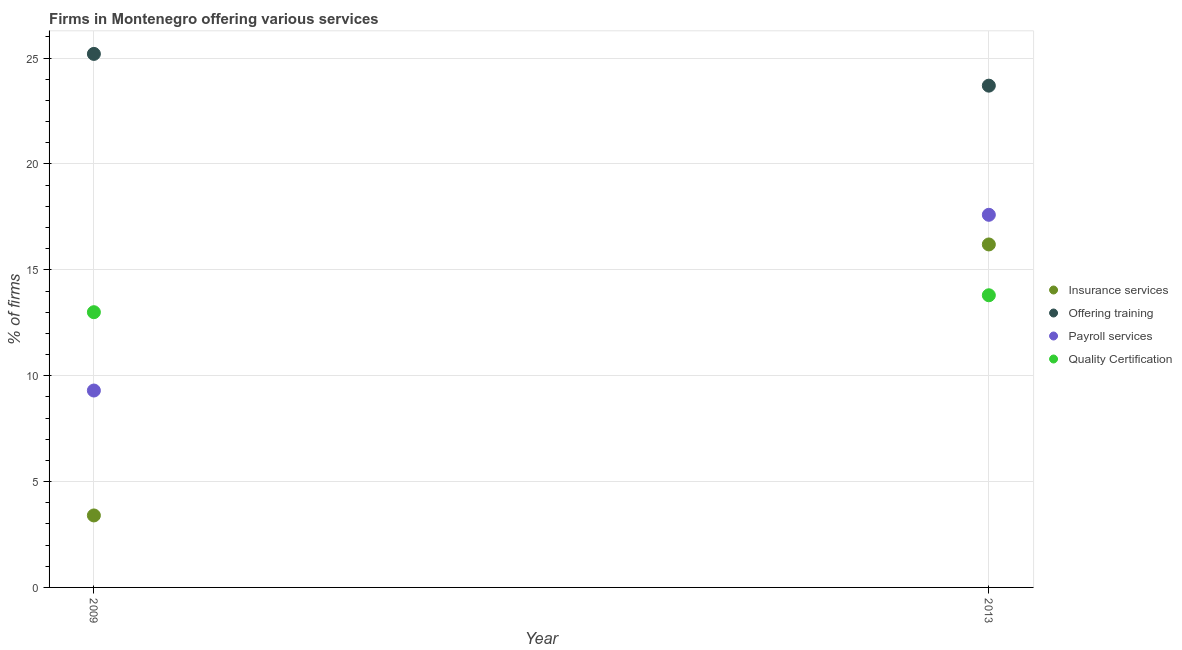What is the percentage of firms offering quality certification in 2013?
Your response must be concise. 13.8. Across all years, what is the maximum percentage of firms offering training?
Give a very brief answer. 25.2. In which year was the percentage of firms offering insurance services maximum?
Your answer should be very brief. 2013. In which year was the percentage of firms offering quality certification minimum?
Give a very brief answer. 2009. What is the total percentage of firms offering quality certification in the graph?
Give a very brief answer. 26.8. What is the difference between the percentage of firms offering insurance services in 2009 and that in 2013?
Your answer should be very brief. -12.8. What is the difference between the percentage of firms offering payroll services in 2013 and the percentage of firms offering training in 2009?
Provide a short and direct response. -7.6. What is the average percentage of firms offering insurance services per year?
Your response must be concise. 9.8. In the year 2013, what is the difference between the percentage of firms offering training and percentage of firms offering payroll services?
Your response must be concise. 6.1. What is the ratio of the percentage of firms offering payroll services in 2009 to that in 2013?
Provide a succinct answer. 0.53. Is the percentage of firms offering insurance services in 2009 less than that in 2013?
Give a very brief answer. Yes. In how many years, is the percentage of firms offering payroll services greater than the average percentage of firms offering payroll services taken over all years?
Give a very brief answer. 1. Is it the case that in every year, the sum of the percentage of firms offering insurance services and percentage of firms offering training is greater than the sum of percentage of firms offering payroll services and percentage of firms offering quality certification?
Give a very brief answer. Yes. Is it the case that in every year, the sum of the percentage of firms offering insurance services and percentage of firms offering training is greater than the percentage of firms offering payroll services?
Ensure brevity in your answer.  Yes. Is the percentage of firms offering payroll services strictly less than the percentage of firms offering training over the years?
Provide a short and direct response. Yes. How many years are there in the graph?
Give a very brief answer. 2. What is the difference between two consecutive major ticks on the Y-axis?
Your answer should be very brief. 5. Are the values on the major ticks of Y-axis written in scientific E-notation?
Your answer should be very brief. No. Does the graph contain grids?
Provide a succinct answer. Yes. Where does the legend appear in the graph?
Your answer should be compact. Center right. How are the legend labels stacked?
Your answer should be compact. Vertical. What is the title of the graph?
Your response must be concise. Firms in Montenegro offering various services . What is the label or title of the X-axis?
Offer a terse response. Year. What is the label or title of the Y-axis?
Your response must be concise. % of firms. What is the % of firms of Insurance services in 2009?
Provide a short and direct response. 3.4. What is the % of firms of Offering training in 2009?
Offer a very short reply. 25.2. What is the % of firms of Quality Certification in 2009?
Offer a terse response. 13. What is the % of firms of Offering training in 2013?
Your answer should be very brief. 23.7. What is the % of firms in Quality Certification in 2013?
Offer a terse response. 13.8. Across all years, what is the maximum % of firms in Offering training?
Ensure brevity in your answer.  25.2. Across all years, what is the minimum % of firms of Offering training?
Your answer should be compact. 23.7. Across all years, what is the minimum % of firms of Payroll services?
Offer a terse response. 9.3. Across all years, what is the minimum % of firms of Quality Certification?
Offer a very short reply. 13. What is the total % of firms in Insurance services in the graph?
Offer a very short reply. 19.6. What is the total % of firms of Offering training in the graph?
Offer a very short reply. 48.9. What is the total % of firms of Payroll services in the graph?
Your answer should be compact. 26.9. What is the total % of firms of Quality Certification in the graph?
Your answer should be compact. 26.8. What is the difference between the % of firms of Insurance services in 2009 and that in 2013?
Give a very brief answer. -12.8. What is the difference between the % of firms in Offering training in 2009 and that in 2013?
Your answer should be very brief. 1.5. What is the difference between the % of firms in Payroll services in 2009 and that in 2013?
Ensure brevity in your answer.  -8.3. What is the difference between the % of firms of Quality Certification in 2009 and that in 2013?
Keep it short and to the point. -0.8. What is the difference between the % of firms in Insurance services in 2009 and the % of firms in Offering training in 2013?
Provide a succinct answer. -20.3. What is the difference between the % of firms of Insurance services in 2009 and the % of firms of Payroll services in 2013?
Offer a terse response. -14.2. What is the difference between the % of firms of Insurance services in 2009 and the % of firms of Quality Certification in 2013?
Offer a very short reply. -10.4. What is the difference between the % of firms in Offering training in 2009 and the % of firms in Payroll services in 2013?
Your response must be concise. 7.6. What is the difference between the % of firms in Payroll services in 2009 and the % of firms in Quality Certification in 2013?
Keep it short and to the point. -4.5. What is the average % of firms of Offering training per year?
Provide a succinct answer. 24.45. What is the average % of firms of Payroll services per year?
Provide a succinct answer. 13.45. In the year 2009, what is the difference between the % of firms in Insurance services and % of firms in Offering training?
Ensure brevity in your answer.  -21.8. In the year 2009, what is the difference between the % of firms in Insurance services and % of firms in Payroll services?
Make the answer very short. -5.9. In the year 2009, what is the difference between the % of firms in Insurance services and % of firms in Quality Certification?
Provide a succinct answer. -9.6. In the year 2009, what is the difference between the % of firms in Offering training and % of firms in Payroll services?
Keep it short and to the point. 15.9. In the year 2009, what is the difference between the % of firms in Offering training and % of firms in Quality Certification?
Your answer should be compact. 12.2. In the year 2009, what is the difference between the % of firms in Payroll services and % of firms in Quality Certification?
Your response must be concise. -3.7. In the year 2013, what is the difference between the % of firms in Insurance services and % of firms in Payroll services?
Your answer should be very brief. -1.4. In the year 2013, what is the difference between the % of firms in Offering training and % of firms in Payroll services?
Make the answer very short. 6.1. In the year 2013, what is the difference between the % of firms in Offering training and % of firms in Quality Certification?
Provide a succinct answer. 9.9. What is the ratio of the % of firms of Insurance services in 2009 to that in 2013?
Give a very brief answer. 0.21. What is the ratio of the % of firms in Offering training in 2009 to that in 2013?
Offer a very short reply. 1.06. What is the ratio of the % of firms in Payroll services in 2009 to that in 2013?
Provide a succinct answer. 0.53. What is the ratio of the % of firms in Quality Certification in 2009 to that in 2013?
Your answer should be very brief. 0.94. What is the difference between the highest and the second highest % of firms of Insurance services?
Offer a terse response. 12.8. What is the difference between the highest and the second highest % of firms of Offering training?
Your response must be concise. 1.5. What is the difference between the highest and the second highest % of firms of Payroll services?
Your response must be concise. 8.3. What is the difference between the highest and the lowest % of firms in Payroll services?
Your response must be concise. 8.3. 